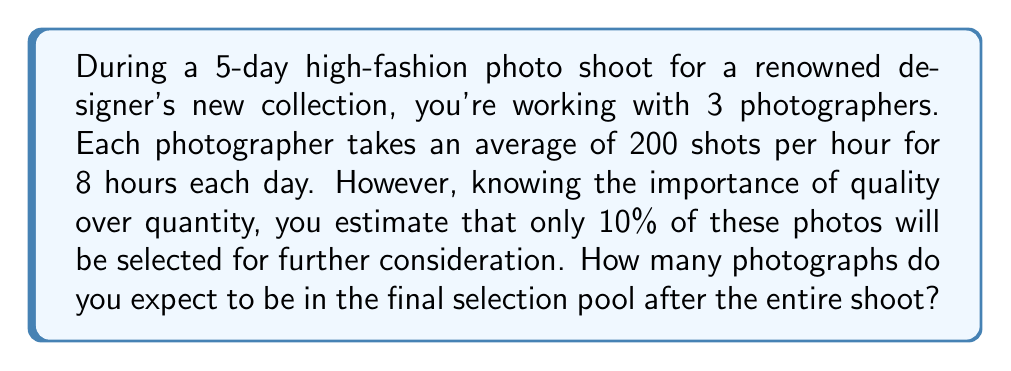Help me with this question. Let's break this down step-by-step:

1. Calculate the total number of hours for the shoot:
   $$ 5 \text{ days} \times 8 \text{ hours/day} = 40 \text{ hours} $$

2. Calculate the total number of photos taken per hour by all photographers:
   $$ 3 \text{ photographers} \times 200 \text{ photos/hour} = 600 \text{ photos/hour} $$

3. Calculate the total number of photos taken during the entire shoot:
   $$ 40 \text{ hours} \times 600 \text{ photos/hour} = 24,000 \text{ photos} $$

4. Calculate 10% of the total photos for the final selection pool:
   $$ 24,000 \text{ photos} \times 0.10 = 2,400 \text{ photos} $$

Therefore, you can expect 2,400 photographs to be in the final selection pool after the entire shoot.
Answer: 2,400 photos 